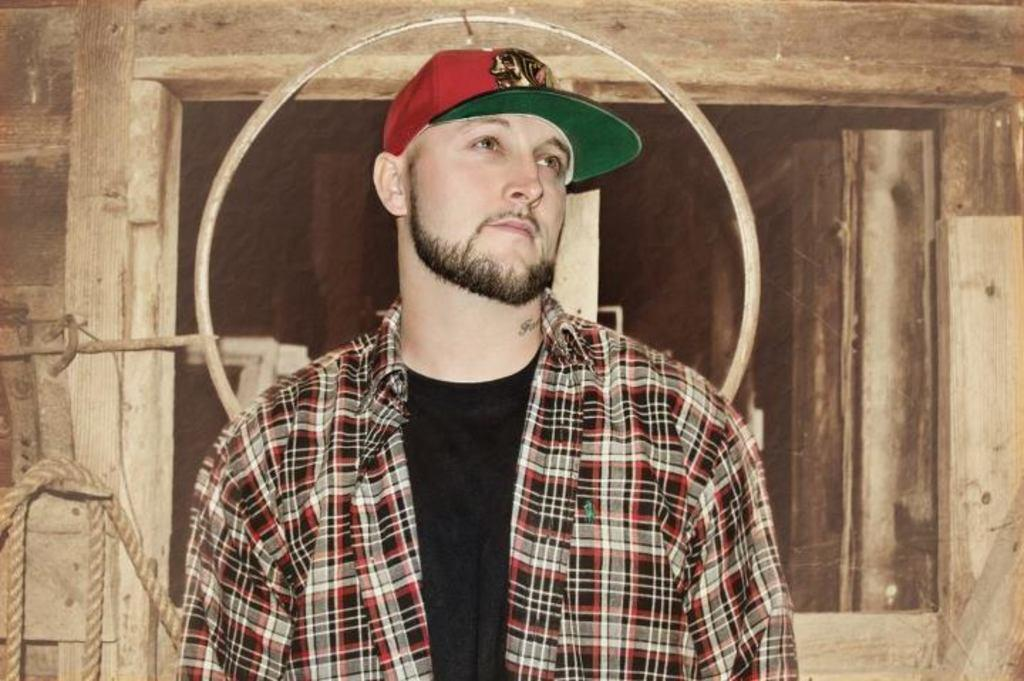What is the main subject in the foreground of the image? There is a man standing in the foreground of the image. What type of structure can be seen in the background of the image? There is a wooden wall in the background of the image. What is the thin, linear object visible in the background of the image? There is a thread visible in the background of the image. What object in the background of the image resembles a window? There is a window-like object in the background of the image. What type of comb is the man using in the image? There is no comb present in the image. What type of chain is hanging from the wooden wall in the image? There is no chain visible in the image. 